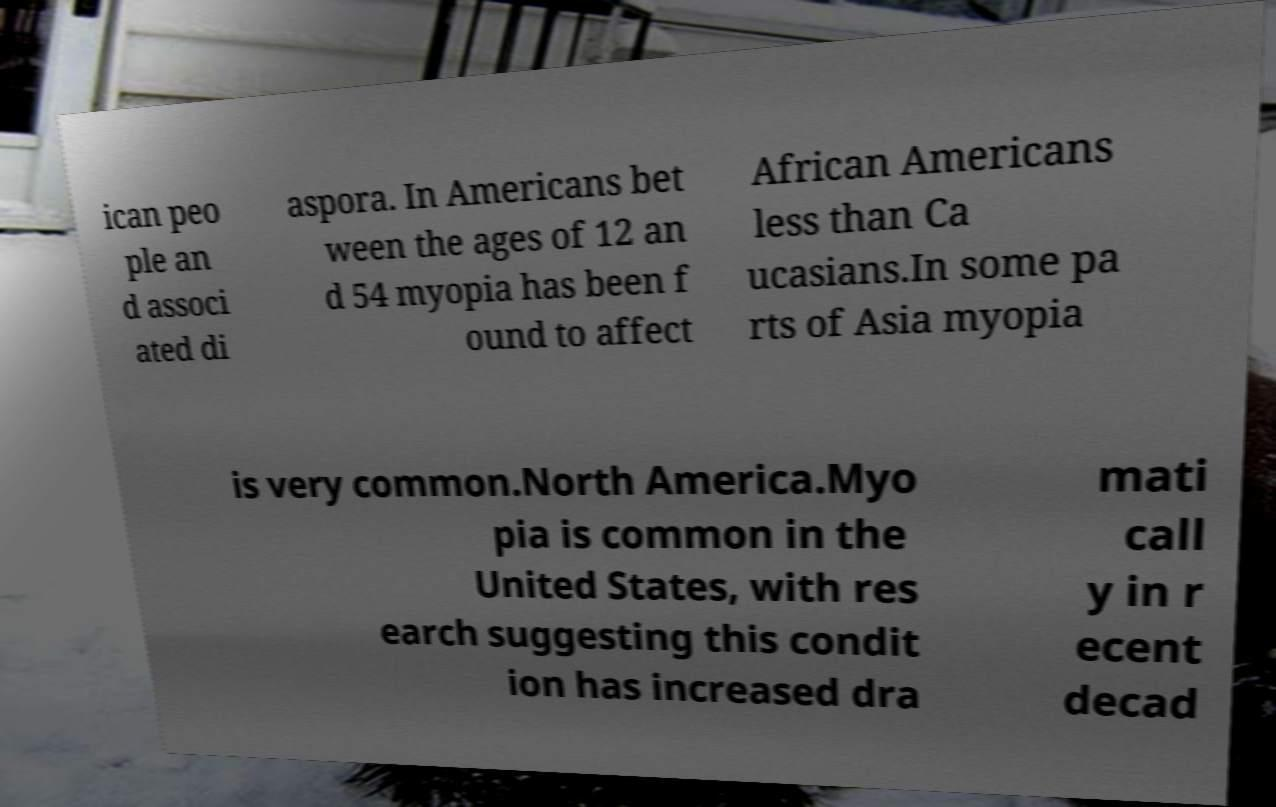For documentation purposes, I need the text within this image transcribed. Could you provide that? ican peo ple an d associ ated di aspora. In Americans bet ween the ages of 12 an d 54 myopia has been f ound to affect African Americans less than Ca ucasians.In some pa rts of Asia myopia is very common.North America.Myo pia is common in the United States, with res earch suggesting this condit ion has increased dra mati call y in r ecent decad 